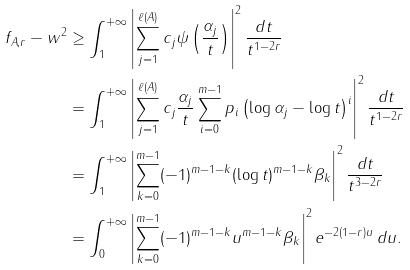Convert formula to latex. <formula><loc_0><loc_0><loc_500><loc_500>\| f _ { A , r } - w \| ^ { 2 } & \geq \int _ { 1 } ^ { + \infty } \left | \sum _ { j = 1 } ^ { \ell ( A ) } c _ { j } \psi \left ( \frac { \alpha _ { j } } { t } \right ) \right | ^ { 2 } \frac { d t } { t ^ { 1 - 2 r } } \\ & = \int _ { 1 } ^ { + \infty } \left | \sum _ { j = 1 } ^ { \ell ( A ) } c _ { j } \frac { \alpha _ { j } } { t } \sum _ { i = 0 } ^ { m - 1 } p _ { i } \left ( \log \alpha _ { j } - \log t \right ) ^ { i } \right | ^ { 2 } \frac { d t } { t ^ { 1 - 2 r } } \\ & = \int _ { 1 } ^ { + \infty } \left | \sum _ { k = 0 } ^ { m - 1 } ( - 1 ) ^ { m - 1 - k } ( \log t ) ^ { m - 1 - k } \beta _ { k } \right | ^ { 2 } \frac { d t } { t ^ { 3 - 2 r } } \\ & = \int _ { 0 } ^ { + \infty } \left | \sum _ { k = 0 } ^ { m - 1 } ( - 1 ) ^ { m - 1 - k } u ^ { m - 1 - k } \beta _ { k } \right | ^ { 2 } e ^ { - 2 ( 1 - r ) u } \, d u .</formula> 